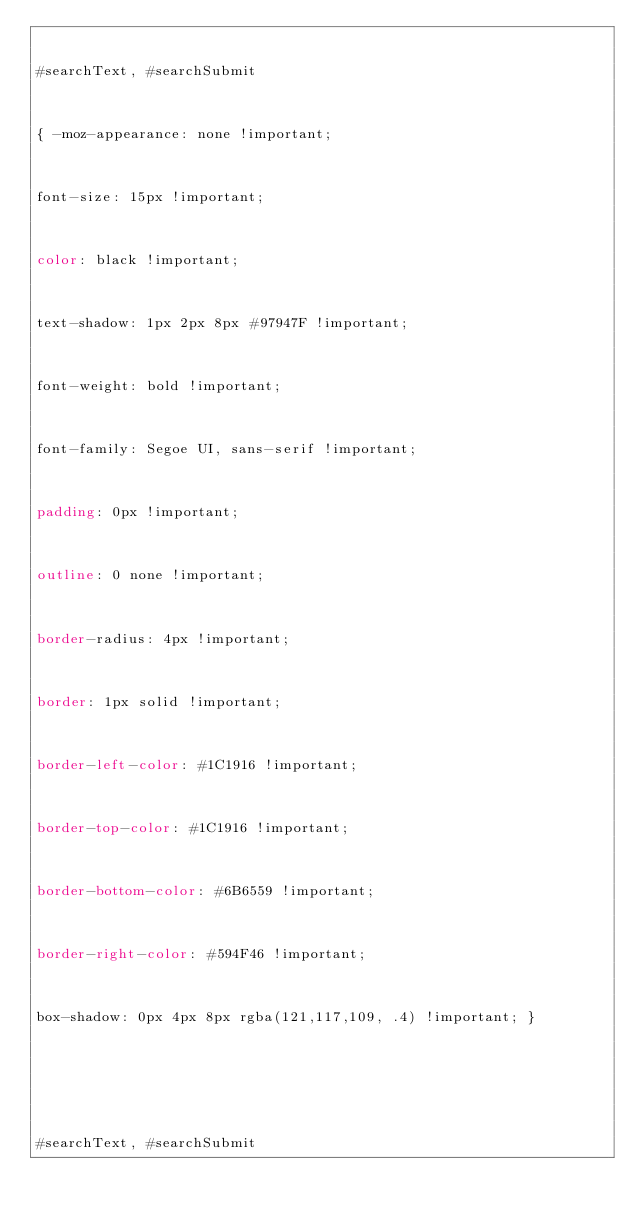Convert code to text. <code><loc_0><loc_0><loc_500><loc_500><_CSS_>

#searchText, #searchSubmit



{ -moz-appearance: none !important; 



font-size: 15px !important;



color: black !important;



text-shadow: 1px 2px 8px #97947F !important;



font-weight: bold !important;



font-family: Segoe UI, sans-serif !important;



padding: 0px !important;



outline: 0 none !important;



border-radius: 4px !important;



border: 1px solid !important;



border-left-color: #1C1916 !important;



border-top-color: #1C1916 !important; 



border-bottom-color: #6B6559 !important;



border-right-color: #594F46 !important;



box-shadow: 0px 4px 8px rgba(121,117,109, .4) !important; }







#searchText, #searchSubmit


</code> 